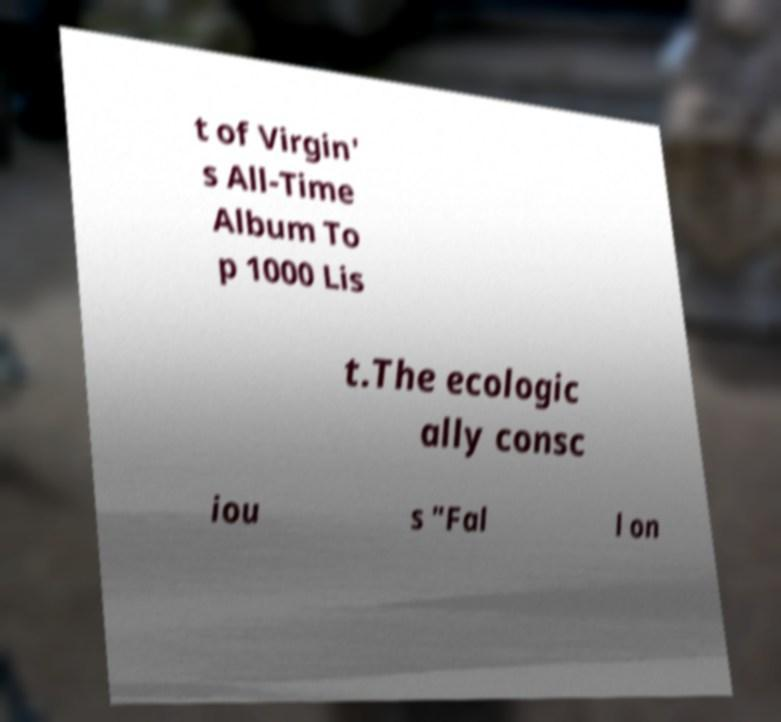Could you assist in decoding the text presented in this image and type it out clearly? t of Virgin' s All-Time Album To p 1000 Lis t.The ecologic ally consc iou s "Fal l on 